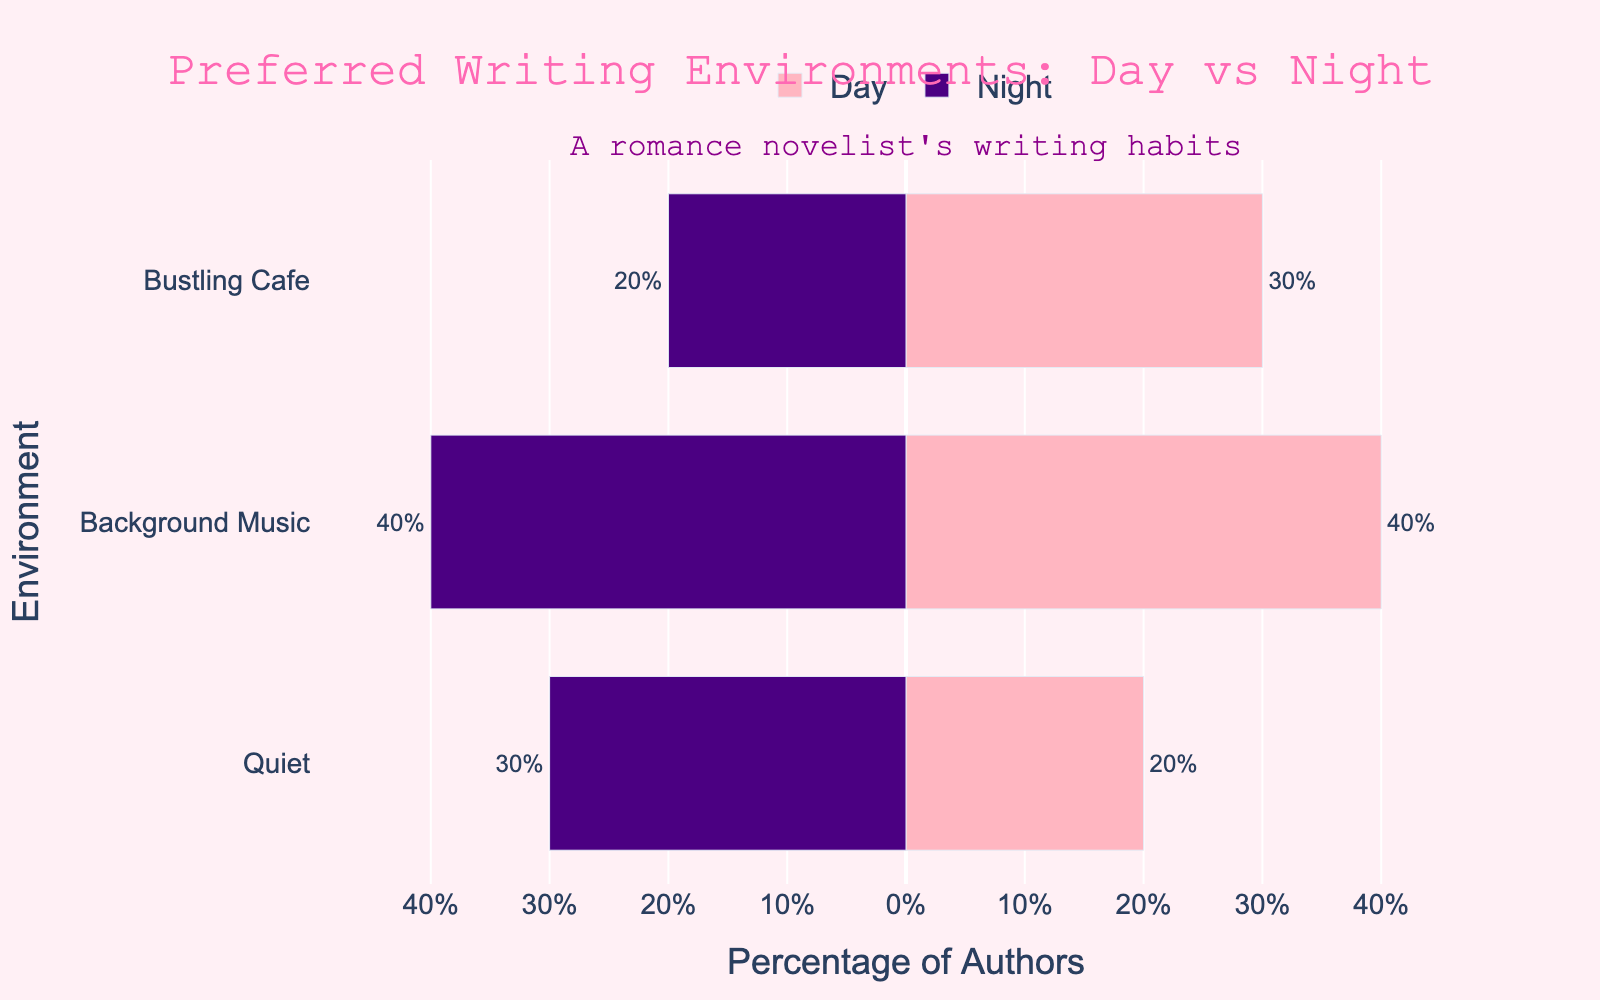Which environment has the highest percentage of authors who prefer writing during the day? Looking at the bars associated with the "Day" period, the longest one is for "Background Music" at 40%.
Answer: Background Music Which environment has the lowest percentage of authors who prefer writing at night? Observing the bars for the "Night" period, the shortest one is for "Bustling Cafe" at 20%.
Answer: Bustling Cafe How does the percentage of authors who prefer a quiet environment differ between day and night? The percentage for "Quiet" is 20% during the day and 30% during the night. The difference is 30% - 20% = 10%.
Answer: 10% Compare the preferred environments for day writing. Which two environments have an equal percentage of authors? Examining the "Day" period bars, "Quiet" has 20%, "Background Music" has 40%, and "Bustling Cafe" has 30%. None of these percentages match, so there is no equal percentage.
Answer: None Calculate the average percentage of authors who prefer background music regardless of writing period. Both "Day" and "Night" periods for "Background Music" show 40%. So, the average is (40% + 40%) / 2 = 40%.
Answer: 40% What is the total percentage of authors who prefer writing in a bustling cafe, irrespective of the time of day? Adding the percentages from both "Day" (30%) and "Night" (20%) periods: 30% + 20% = 50%.
Answer: 50% Which writing environment shows the biggest difference in preference between day and night? Calculating differences: Quiet (30% - 20% = 10%), Background Music (40% - 40% = 0%), Bustling Cafe (30% - 20% = 10%). The biggest difference is between Quiet and Bustling Cafe, both at 10%.
Answer: Quiet and Bustling Cafe What percentage of authors prefer writing during the day in either a quiet environment or a bustling cafe? Adding the percentages of "Day" period for Quiet (20%) and Bustling Cafe (30%): 20% + 30% = 50%.
Answer: 50% 